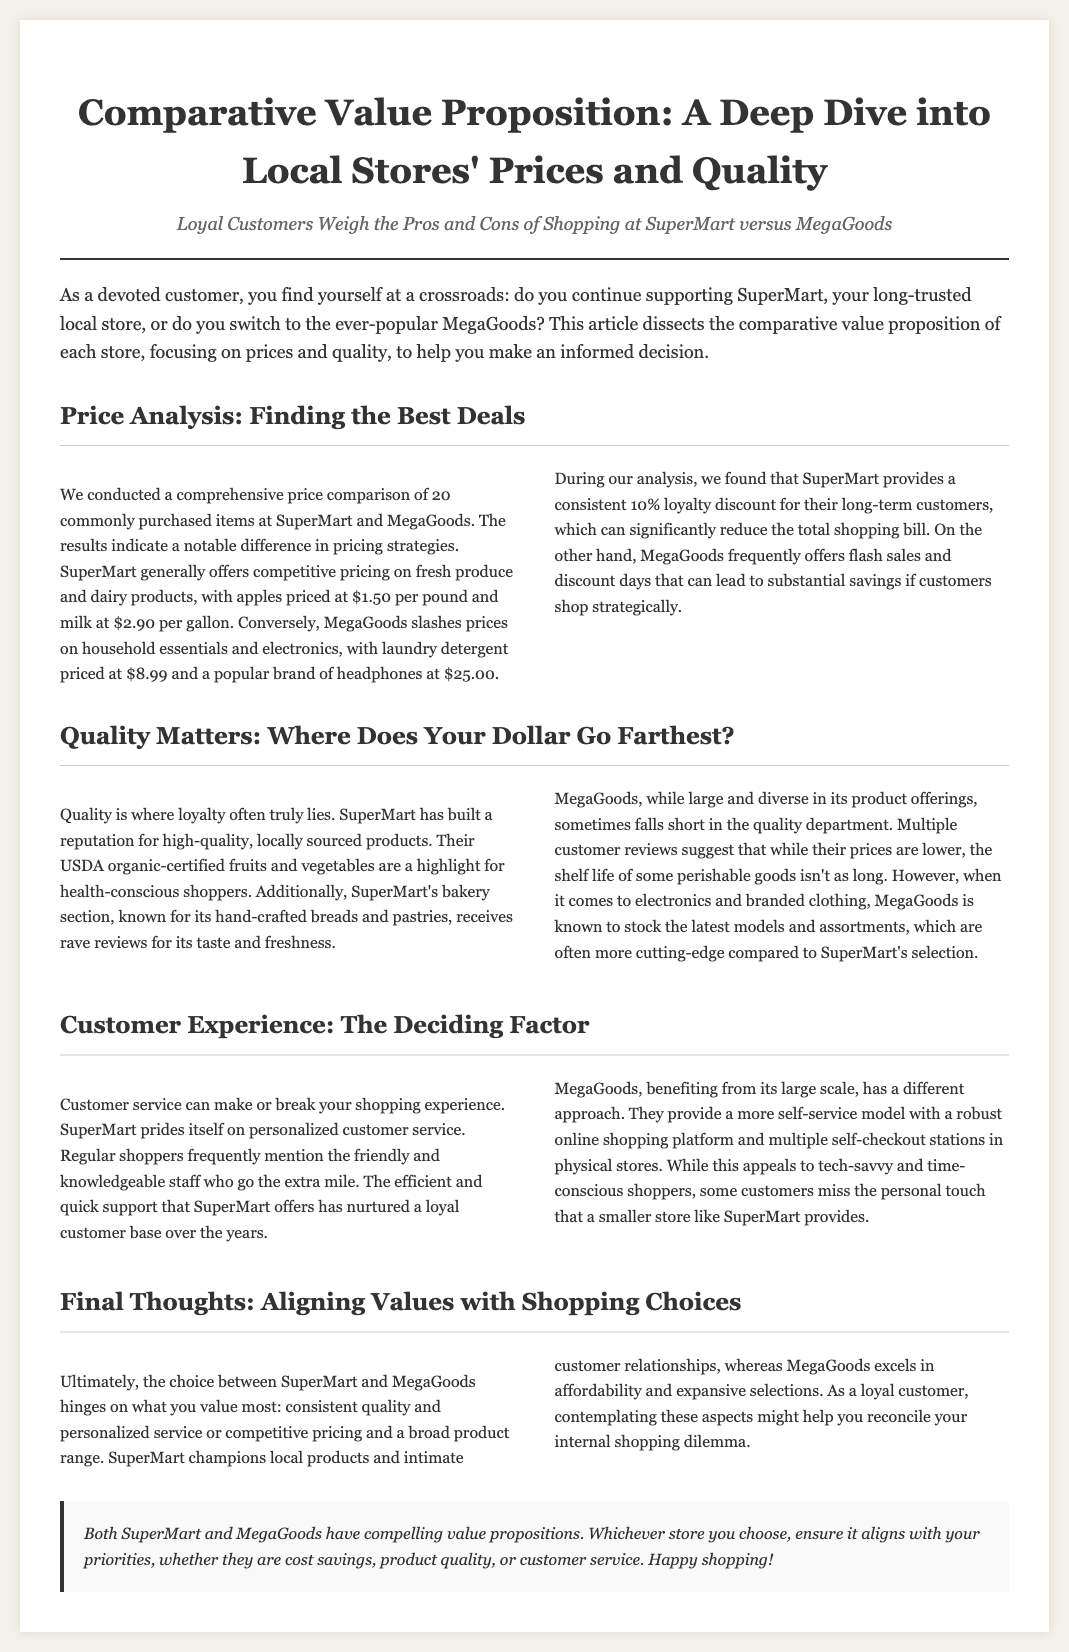What is the price of apples at SuperMart? The document states that apples are priced at $1.50 per pound at SuperMart.
Answer: $1.50 per pound What discount does SuperMart offer to long-term customers? The text mentions that SuperMart provides a consistent 10% loyalty discount for their long-term customers.
Answer: 10% loyalty discount Which store is known for its hand-crafted breads and pastries? The document indicates that SuperMart's bakery section is known for its hand-crafted breads and pastries.
Answer: SuperMart How does MegaGoods appeal to tech-savvy shoppers? The analysis points out that MegaGoods provides a robust online shopping platform and multiple self-checkout stations.
Answer: Online shopping platform and self-checkout stations What is the key factor that could sway a customer's decision between the two stores? The conclusion suggests that the choice hinges on priorities such as cost savings, product quality, or customer service.
Answer: Priorities What type of products does MegaGoods slash prices on? The document specifies that MegaGoods slashes prices on household essentials and electronics.
Answer: Household essentials and electronics What is a notable feature of SuperMart's customer service? The article highlights that SuperMart prides itself on personalized customer service.
Answer: Personalized customer service Which store is recognized for high-quality, locally sourced products? SuperMart is noted for its high-quality, locally sourced products.
Answer: SuperMart 